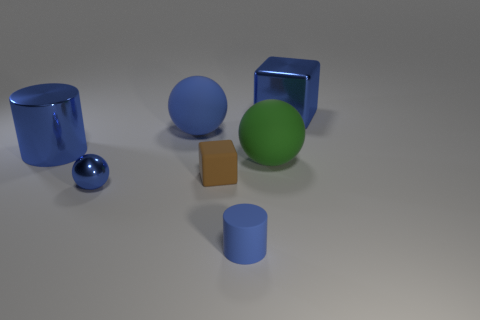Add 2 large green rubber objects. How many objects exist? 9 Subtract all spheres. How many objects are left? 4 Add 7 green matte balls. How many green matte balls are left? 8 Add 4 big cyan metal spheres. How many big cyan metal spheres exist? 4 Subtract 0 green cubes. How many objects are left? 7 Subtract all small gray cubes. Subtract all tiny blue things. How many objects are left? 5 